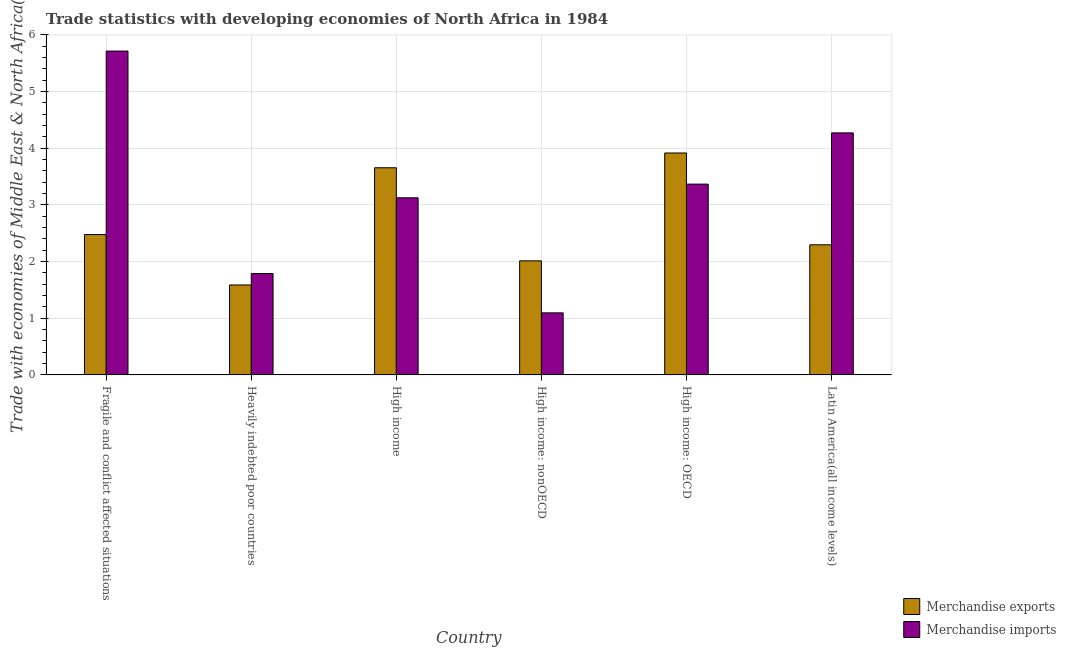How many different coloured bars are there?
Keep it short and to the point. 2. How many bars are there on the 4th tick from the left?
Your response must be concise. 2. How many bars are there on the 1st tick from the right?
Keep it short and to the point. 2. What is the label of the 4th group of bars from the left?
Provide a short and direct response. High income: nonOECD. What is the merchandise exports in High income: nonOECD?
Offer a terse response. 2.01. Across all countries, what is the maximum merchandise imports?
Keep it short and to the point. 5.71. Across all countries, what is the minimum merchandise exports?
Your answer should be very brief. 1.59. In which country was the merchandise imports maximum?
Provide a short and direct response. Fragile and conflict affected situations. In which country was the merchandise exports minimum?
Make the answer very short. Heavily indebted poor countries. What is the total merchandise exports in the graph?
Your answer should be compact. 15.94. What is the difference between the merchandise imports in High income and that in High income: OECD?
Offer a terse response. -0.24. What is the difference between the merchandise exports in Latin America(all income levels) and the merchandise imports in Heavily indebted poor countries?
Provide a succinct answer. 0.51. What is the average merchandise exports per country?
Provide a short and direct response. 2.66. What is the difference between the merchandise exports and merchandise imports in Heavily indebted poor countries?
Offer a terse response. -0.2. In how many countries, is the merchandise exports greater than 1 %?
Your answer should be compact. 6. What is the ratio of the merchandise imports in Heavily indebted poor countries to that in Latin America(all income levels)?
Offer a terse response. 0.42. Is the difference between the merchandise imports in Heavily indebted poor countries and High income greater than the difference between the merchandise exports in Heavily indebted poor countries and High income?
Your answer should be compact. Yes. What is the difference between the highest and the second highest merchandise exports?
Provide a succinct answer. 0.26. What is the difference between the highest and the lowest merchandise exports?
Keep it short and to the point. 2.33. In how many countries, is the merchandise exports greater than the average merchandise exports taken over all countries?
Your answer should be very brief. 2. Is the sum of the merchandise exports in Heavily indebted poor countries and High income: OECD greater than the maximum merchandise imports across all countries?
Keep it short and to the point. No. What does the 1st bar from the left in High income: OECD represents?
Offer a very short reply. Merchandise exports. How many bars are there?
Give a very brief answer. 12. Are all the bars in the graph horizontal?
Keep it short and to the point. No. Are the values on the major ticks of Y-axis written in scientific E-notation?
Make the answer very short. No. Does the graph contain grids?
Your answer should be very brief. Yes. How many legend labels are there?
Make the answer very short. 2. What is the title of the graph?
Keep it short and to the point. Trade statistics with developing economies of North Africa in 1984. Does "Health Care" appear as one of the legend labels in the graph?
Your answer should be compact. No. What is the label or title of the Y-axis?
Your answer should be very brief. Trade with economies of Middle East & North Africa(%). What is the Trade with economies of Middle East & North Africa(%) in Merchandise exports in Fragile and conflict affected situations?
Your answer should be very brief. 2.48. What is the Trade with economies of Middle East & North Africa(%) in Merchandise imports in Fragile and conflict affected situations?
Your answer should be compact. 5.71. What is the Trade with economies of Middle East & North Africa(%) of Merchandise exports in Heavily indebted poor countries?
Keep it short and to the point. 1.59. What is the Trade with economies of Middle East & North Africa(%) of Merchandise imports in Heavily indebted poor countries?
Your response must be concise. 1.79. What is the Trade with economies of Middle East & North Africa(%) of Merchandise exports in High income?
Provide a succinct answer. 3.66. What is the Trade with economies of Middle East & North Africa(%) in Merchandise imports in High income?
Provide a short and direct response. 3.13. What is the Trade with economies of Middle East & North Africa(%) of Merchandise exports in High income: nonOECD?
Your response must be concise. 2.01. What is the Trade with economies of Middle East & North Africa(%) in Merchandise imports in High income: nonOECD?
Your response must be concise. 1.1. What is the Trade with economies of Middle East & North Africa(%) in Merchandise exports in High income: OECD?
Keep it short and to the point. 3.92. What is the Trade with economies of Middle East & North Africa(%) in Merchandise imports in High income: OECD?
Keep it short and to the point. 3.37. What is the Trade with economies of Middle East & North Africa(%) of Merchandise exports in Latin America(all income levels)?
Provide a succinct answer. 2.3. What is the Trade with economies of Middle East & North Africa(%) in Merchandise imports in Latin America(all income levels)?
Give a very brief answer. 4.27. Across all countries, what is the maximum Trade with economies of Middle East & North Africa(%) of Merchandise exports?
Give a very brief answer. 3.92. Across all countries, what is the maximum Trade with economies of Middle East & North Africa(%) in Merchandise imports?
Offer a very short reply. 5.71. Across all countries, what is the minimum Trade with economies of Middle East & North Africa(%) of Merchandise exports?
Offer a terse response. 1.59. Across all countries, what is the minimum Trade with economies of Middle East & North Africa(%) of Merchandise imports?
Offer a very short reply. 1.1. What is the total Trade with economies of Middle East & North Africa(%) of Merchandise exports in the graph?
Provide a succinct answer. 15.94. What is the total Trade with economies of Middle East & North Africa(%) of Merchandise imports in the graph?
Ensure brevity in your answer.  19.36. What is the difference between the Trade with economies of Middle East & North Africa(%) in Merchandise exports in Fragile and conflict affected situations and that in Heavily indebted poor countries?
Make the answer very short. 0.89. What is the difference between the Trade with economies of Middle East & North Africa(%) in Merchandise imports in Fragile and conflict affected situations and that in Heavily indebted poor countries?
Provide a succinct answer. 3.93. What is the difference between the Trade with economies of Middle East & North Africa(%) in Merchandise exports in Fragile and conflict affected situations and that in High income?
Provide a short and direct response. -1.18. What is the difference between the Trade with economies of Middle East & North Africa(%) of Merchandise imports in Fragile and conflict affected situations and that in High income?
Offer a very short reply. 2.59. What is the difference between the Trade with economies of Middle East & North Africa(%) of Merchandise exports in Fragile and conflict affected situations and that in High income: nonOECD?
Give a very brief answer. 0.46. What is the difference between the Trade with economies of Middle East & North Africa(%) in Merchandise imports in Fragile and conflict affected situations and that in High income: nonOECD?
Make the answer very short. 4.62. What is the difference between the Trade with economies of Middle East & North Africa(%) in Merchandise exports in Fragile and conflict affected situations and that in High income: OECD?
Make the answer very short. -1.44. What is the difference between the Trade with economies of Middle East & North Africa(%) of Merchandise imports in Fragile and conflict affected situations and that in High income: OECD?
Ensure brevity in your answer.  2.35. What is the difference between the Trade with economies of Middle East & North Africa(%) of Merchandise exports in Fragile and conflict affected situations and that in Latin America(all income levels)?
Your answer should be compact. 0.18. What is the difference between the Trade with economies of Middle East & North Africa(%) of Merchandise imports in Fragile and conflict affected situations and that in Latin America(all income levels)?
Offer a terse response. 1.44. What is the difference between the Trade with economies of Middle East & North Africa(%) of Merchandise exports in Heavily indebted poor countries and that in High income?
Your response must be concise. -2.07. What is the difference between the Trade with economies of Middle East & North Africa(%) in Merchandise imports in Heavily indebted poor countries and that in High income?
Ensure brevity in your answer.  -1.34. What is the difference between the Trade with economies of Middle East & North Africa(%) of Merchandise exports in Heavily indebted poor countries and that in High income: nonOECD?
Make the answer very short. -0.43. What is the difference between the Trade with economies of Middle East & North Africa(%) in Merchandise imports in Heavily indebted poor countries and that in High income: nonOECD?
Offer a terse response. 0.69. What is the difference between the Trade with economies of Middle East & North Africa(%) in Merchandise exports in Heavily indebted poor countries and that in High income: OECD?
Offer a very short reply. -2.33. What is the difference between the Trade with economies of Middle East & North Africa(%) of Merchandise imports in Heavily indebted poor countries and that in High income: OECD?
Your answer should be compact. -1.58. What is the difference between the Trade with economies of Middle East & North Africa(%) in Merchandise exports in Heavily indebted poor countries and that in Latin America(all income levels)?
Keep it short and to the point. -0.71. What is the difference between the Trade with economies of Middle East & North Africa(%) in Merchandise imports in Heavily indebted poor countries and that in Latin America(all income levels)?
Your answer should be compact. -2.48. What is the difference between the Trade with economies of Middle East & North Africa(%) of Merchandise exports in High income and that in High income: nonOECD?
Give a very brief answer. 1.64. What is the difference between the Trade with economies of Middle East & North Africa(%) of Merchandise imports in High income and that in High income: nonOECD?
Your answer should be very brief. 2.03. What is the difference between the Trade with economies of Middle East & North Africa(%) in Merchandise exports in High income and that in High income: OECD?
Provide a succinct answer. -0.26. What is the difference between the Trade with economies of Middle East & North Africa(%) of Merchandise imports in High income and that in High income: OECD?
Your answer should be very brief. -0.24. What is the difference between the Trade with economies of Middle East & North Africa(%) of Merchandise exports in High income and that in Latin America(all income levels)?
Ensure brevity in your answer.  1.36. What is the difference between the Trade with economies of Middle East & North Africa(%) in Merchandise imports in High income and that in Latin America(all income levels)?
Give a very brief answer. -1.15. What is the difference between the Trade with economies of Middle East & North Africa(%) of Merchandise exports in High income: nonOECD and that in High income: OECD?
Keep it short and to the point. -1.9. What is the difference between the Trade with economies of Middle East & North Africa(%) of Merchandise imports in High income: nonOECD and that in High income: OECD?
Ensure brevity in your answer.  -2.27. What is the difference between the Trade with economies of Middle East & North Africa(%) in Merchandise exports in High income: nonOECD and that in Latin America(all income levels)?
Provide a succinct answer. -0.28. What is the difference between the Trade with economies of Middle East & North Africa(%) in Merchandise imports in High income: nonOECD and that in Latin America(all income levels)?
Provide a short and direct response. -3.18. What is the difference between the Trade with economies of Middle East & North Africa(%) of Merchandise exports in High income: OECD and that in Latin America(all income levels)?
Keep it short and to the point. 1.62. What is the difference between the Trade with economies of Middle East & North Africa(%) in Merchandise imports in High income: OECD and that in Latin America(all income levels)?
Your answer should be very brief. -0.9. What is the difference between the Trade with economies of Middle East & North Africa(%) of Merchandise exports in Fragile and conflict affected situations and the Trade with economies of Middle East & North Africa(%) of Merchandise imports in Heavily indebted poor countries?
Your answer should be very brief. 0.69. What is the difference between the Trade with economies of Middle East & North Africa(%) in Merchandise exports in Fragile and conflict affected situations and the Trade with economies of Middle East & North Africa(%) in Merchandise imports in High income?
Offer a very short reply. -0.65. What is the difference between the Trade with economies of Middle East & North Africa(%) of Merchandise exports in Fragile and conflict affected situations and the Trade with economies of Middle East & North Africa(%) of Merchandise imports in High income: nonOECD?
Offer a very short reply. 1.38. What is the difference between the Trade with economies of Middle East & North Africa(%) in Merchandise exports in Fragile and conflict affected situations and the Trade with economies of Middle East & North Africa(%) in Merchandise imports in High income: OECD?
Keep it short and to the point. -0.89. What is the difference between the Trade with economies of Middle East & North Africa(%) in Merchandise exports in Fragile and conflict affected situations and the Trade with economies of Middle East & North Africa(%) in Merchandise imports in Latin America(all income levels)?
Provide a short and direct response. -1.79. What is the difference between the Trade with economies of Middle East & North Africa(%) of Merchandise exports in Heavily indebted poor countries and the Trade with economies of Middle East & North Africa(%) of Merchandise imports in High income?
Keep it short and to the point. -1.54. What is the difference between the Trade with economies of Middle East & North Africa(%) of Merchandise exports in Heavily indebted poor countries and the Trade with economies of Middle East & North Africa(%) of Merchandise imports in High income: nonOECD?
Provide a succinct answer. 0.49. What is the difference between the Trade with economies of Middle East & North Africa(%) in Merchandise exports in Heavily indebted poor countries and the Trade with economies of Middle East & North Africa(%) in Merchandise imports in High income: OECD?
Make the answer very short. -1.78. What is the difference between the Trade with economies of Middle East & North Africa(%) of Merchandise exports in Heavily indebted poor countries and the Trade with economies of Middle East & North Africa(%) of Merchandise imports in Latin America(all income levels)?
Ensure brevity in your answer.  -2.68. What is the difference between the Trade with economies of Middle East & North Africa(%) in Merchandise exports in High income and the Trade with economies of Middle East & North Africa(%) in Merchandise imports in High income: nonOECD?
Your answer should be compact. 2.56. What is the difference between the Trade with economies of Middle East & North Africa(%) of Merchandise exports in High income and the Trade with economies of Middle East & North Africa(%) of Merchandise imports in High income: OECD?
Make the answer very short. 0.29. What is the difference between the Trade with economies of Middle East & North Africa(%) in Merchandise exports in High income and the Trade with economies of Middle East & North Africa(%) in Merchandise imports in Latin America(all income levels)?
Make the answer very short. -0.62. What is the difference between the Trade with economies of Middle East & North Africa(%) in Merchandise exports in High income: nonOECD and the Trade with economies of Middle East & North Africa(%) in Merchandise imports in High income: OECD?
Provide a short and direct response. -1.35. What is the difference between the Trade with economies of Middle East & North Africa(%) in Merchandise exports in High income: nonOECD and the Trade with economies of Middle East & North Africa(%) in Merchandise imports in Latin America(all income levels)?
Your response must be concise. -2.26. What is the difference between the Trade with economies of Middle East & North Africa(%) in Merchandise exports in High income: OECD and the Trade with economies of Middle East & North Africa(%) in Merchandise imports in Latin America(all income levels)?
Ensure brevity in your answer.  -0.35. What is the average Trade with economies of Middle East & North Africa(%) in Merchandise exports per country?
Provide a short and direct response. 2.66. What is the average Trade with economies of Middle East & North Africa(%) in Merchandise imports per country?
Ensure brevity in your answer.  3.23. What is the difference between the Trade with economies of Middle East & North Africa(%) of Merchandise exports and Trade with economies of Middle East & North Africa(%) of Merchandise imports in Fragile and conflict affected situations?
Make the answer very short. -3.24. What is the difference between the Trade with economies of Middle East & North Africa(%) in Merchandise exports and Trade with economies of Middle East & North Africa(%) in Merchandise imports in Heavily indebted poor countries?
Your response must be concise. -0.2. What is the difference between the Trade with economies of Middle East & North Africa(%) of Merchandise exports and Trade with economies of Middle East & North Africa(%) of Merchandise imports in High income?
Your response must be concise. 0.53. What is the difference between the Trade with economies of Middle East & North Africa(%) in Merchandise exports and Trade with economies of Middle East & North Africa(%) in Merchandise imports in High income: nonOECD?
Ensure brevity in your answer.  0.92. What is the difference between the Trade with economies of Middle East & North Africa(%) in Merchandise exports and Trade with economies of Middle East & North Africa(%) in Merchandise imports in High income: OECD?
Provide a succinct answer. 0.55. What is the difference between the Trade with economies of Middle East & North Africa(%) of Merchandise exports and Trade with economies of Middle East & North Africa(%) of Merchandise imports in Latin America(all income levels)?
Your response must be concise. -1.97. What is the ratio of the Trade with economies of Middle East & North Africa(%) of Merchandise exports in Fragile and conflict affected situations to that in Heavily indebted poor countries?
Your response must be concise. 1.56. What is the ratio of the Trade with economies of Middle East & North Africa(%) of Merchandise imports in Fragile and conflict affected situations to that in Heavily indebted poor countries?
Keep it short and to the point. 3.19. What is the ratio of the Trade with economies of Middle East & North Africa(%) of Merchandise exports in Fragile and conflict affected situations to that in High income?
Give a very brief answer. 0.68. What is the ratio of the Trade with economies of Middle East & North Africa(%) in Merchandise imports in Fragile and conflict affected situations to that in High income?
Ensure brevity in your answer.  1.83. What is the ratio of the Trade with economies of Middle East & North Africa(%) in Merchandise exports in Fragile and conflict affected situations to that in High income: nonOECD?
Your answer should be very brief. 1.23. What is the ratio of the Trade with economies of Middle East & North Africa(%) of Merchandise imports in Fragile and conflict affected situations to that in High income: nonOECD?
Offer a terse response. 5.22. What is the ratio of the Trade with economies of Middle East & North Africa(%) of Merchandise exports in Fragile and conflict affected situations to that in High income: OECD?
Give a very brief answer. 0.63. What is the ratio of the Trade with economies of Middle East & North Africa(%) in Merchandise imports in Fragile and conflict affected situations to that in High income: OECD?
Keep it short and to the point. 1.7. What is the ratio of the Trade with economies of Middle East & North Africa(%) in Merchandise exports in Fragile and conflict affected situations to that in Latin America(all income levels)?
Provide a short and direct response. 1.08. What is the ratio of the Trade with economies of Middle East & North Africa(%) in Merchandise imports in Fragile and conflict affected situations to that in Latin America(all income levels)?
Offer a terse response. 1.34. What is the ratio of the Trade with economies of Middle East & North Africa(%) in Merchandise exports in Heavily indebted poor countries to that in High income?
Your answer should be compact. 0.43. What is the ratio of the Trade with economies of Middle East & North Africa(%) in Merchandise imports in Heavily indebted poor countries to that in High income?
Offer a very short reply. 0.57. What is the ratio of the Trade with economies of Middle East & North Africa(%) in Merchandise exports in Heavily indebted poor countries to that in High income: nonOECD?
Offer a terse response. 0.79. What is the ratio of the Trade with economies of Middle East & North Africa(%) of Merchandise imports in Heavily indebted poor countries to that in High income: nonOECD?
Give a very brief answer. 1.63. What is the ratio of the Trade with economies of Middle East & North Africa(%) of Merchandise exports in Heavily indebted poor countries to that in High income: OECD?
Your answer should be very brief. 0.41. What is the ratio of the Trade with economies of Middle East & North Africa(%) of Merchandise imports in Heavily indebted poor countries to that in High income: OECD?
Keep it short and to the point. 0.53. What is the ratio of the Trade with economies of Middle East & North Africa(%) in Merchandise exports in Heavily indebted poor countries to that in Latin America(all income levels)?
Your answer should be very brief. 0.69. What is the ratio of the Trade with economies of Middle East & North Africa(%) in Merchandise imports in Heavily indebted poor countries to that in Latin America(all income levels)?
Provide a short and direct response. 0.42. What is the ratio of the Trade with economies of Middle East & North Africa(%) of Merchandise exports in High income to that in High income: nonOECD?
Keep it short and to the point. 1.82. What is the ratio of the Trade with economies of Middle East & North Africa(%) in Merchandise imports in High income to that in High income: nonOECD?
Make the answer very short. 2.85. What is the ratio of the Trade with economies of Middle East & North Africa(%) in Merchandise exports in High income to that in High income: OECD?
Your answer should be very brief. 0.93. What is the ratio of the Trade with economies of Middle East & North Africa(%) of Merchandise imports in High income to that in High income: OECD?
Your response must be concise. 0.93. What is the ratio of the Trade with economies of Middle East & North Africa(%) of Merchandise exports in High income to that in Latin America(all income levels)?
Give a very brief answer. 1.59. What is the ratio of the Trade with economies of Middle East & North Africa(%) of Merchandise imports in High income to that in Latin America(all income levels)?
Your answer should be compact. 0.73. What is the ratio of the Trade with economies of Middle East & North Africa(%) of Merchandise exports in High income: nonOECD to that in High income: OECD?
Offer a terse response. 0.51. What is the ratio of the Trade with economies of Middle East & North Africa(%) of Merchandise imports in High income: nonOECD to that in High income: OECD?
Provide a short and direct response. 0.33. What is the ratio of the Trade with economies of Middle East & North Africa(%) of Merchandise exports in High income: nonOECD to that in Latin America(all income levels)?
Keep it short and to the point. 0.88. What is the ratio of the Trade with economies of Middle East & North Africa(%) in Merchandise imports in High income: nonOECD to that in Latin America(all income levels)?
Ensure brevity in your answer.  0.26. What is the ratio of the Trade with economies of Middle East & North Africa(%) of Merchandise exports in High income: OECD to that in Latin America(all income levels)?
Provide a short and direct response. 1.71. What is the ratio of the Trade with economies of Middle East & North Africa(%) of Merchandise imports in High income: OECD to that in Latin America(all income levels)?
Give a very brief answer. 0.79. What is the difference between the highest and the second highest Trade with economies of Middle East & North Africa(%) of Merchandise exports?
Offer a very short reply. 0.26. What is the difference between the highest and the second highest Trade with economies of Middle East & North Africa(%) in Merchandise imports?
Offer a very short reply. 1.44. What is the difference between the highest and the lowest Trade with economies of Middle East & North Africa(%) in Merchandise exports?
Your answer should be compact. 2.33. What is the difference between the highest and the lowest Trade with economies of Middle East & North Africa(%) in Merchandise imports?
Keep it short and to the point. 4.62. 